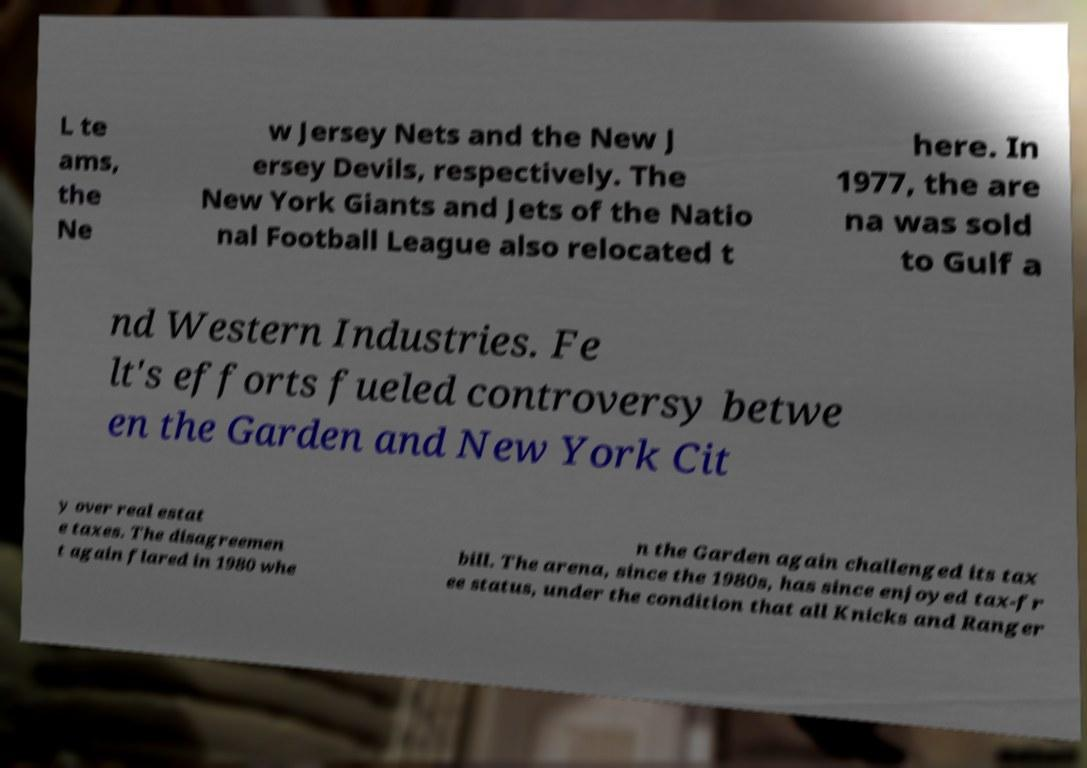Please identify and transcribe the text found in this image. L te ams, the Ne w Jersey Nets and the New J ersey Devils, respectively. The New York Giants and Jets of the Natio nal Football League also relocated t here. In 1977, the are na was sold to Gulf a nd Western Industries. Fe lt's efforts fueled controversy betwe en the Garden and New York Cit y over real estat e taxes. The disagreemen t again flared in 1980 whe n the Garden again challenged its tax bill. The arena, since the 1980s, has since enjoyed tax-fr ee status, under the condition that all Knicks and Ranger 